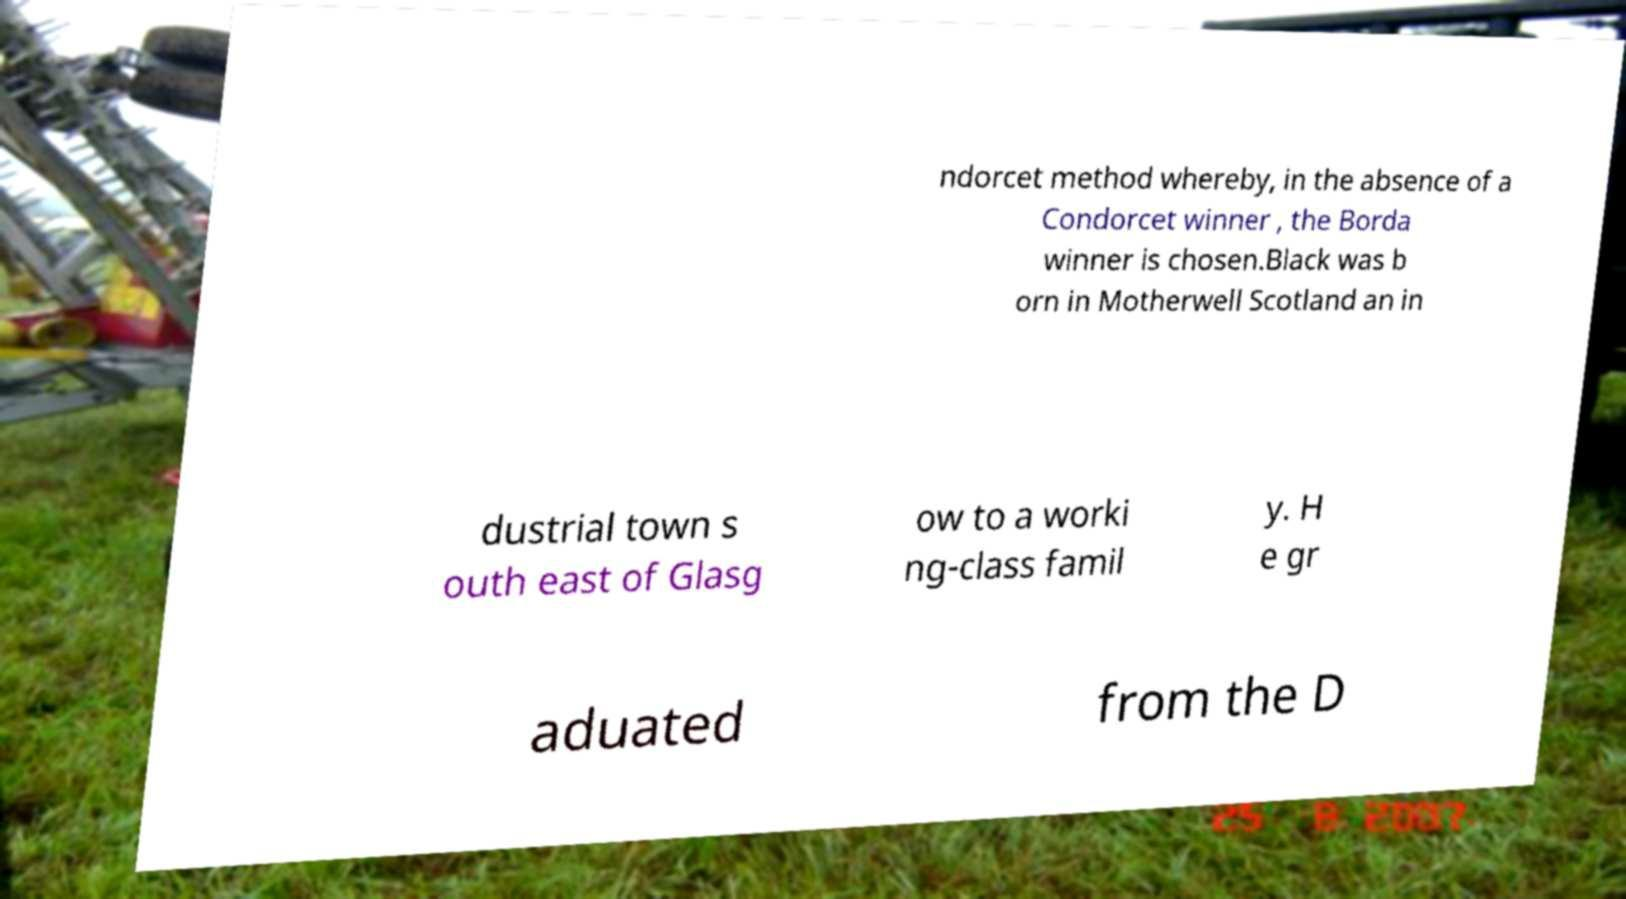Please identify and transcribe the text found in this image. ndorcet method whereby, in the absence of a Condorcet winner , the Borda winner is chosen.Black was b orn in Motherwell Scotland an in dustrial town s outh east of Glasg ow to a worki ng-class famil y. H e gr aduated from the D 